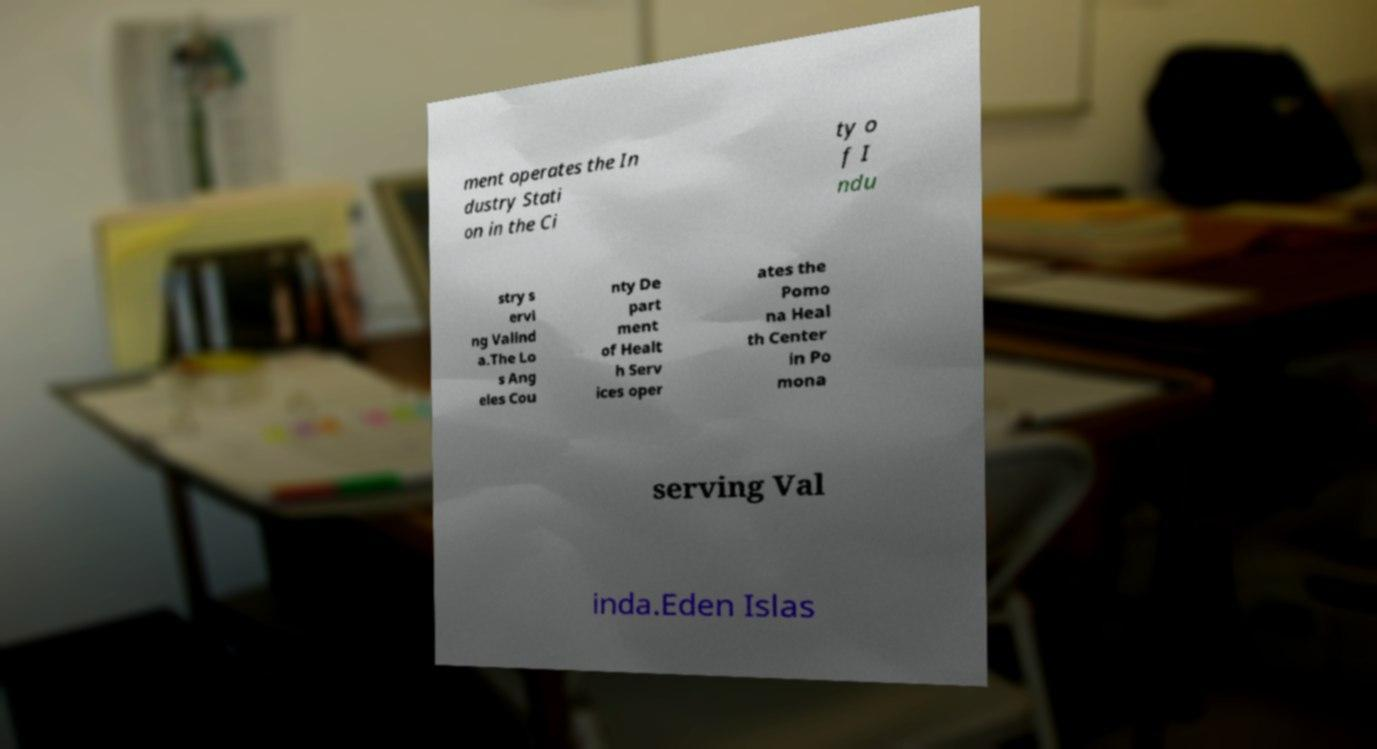Please identify and transcribe the text found in this image. ment operates the In dustry Stati on in the Ci ty o f I ndu stry s ervi ng Valind a.The Lo s Ang eles Cou nty De part ment of Healt h Serv ices oper ates the Pomo na Heal th Center in Po mona serving Val inda.Eden Islas 